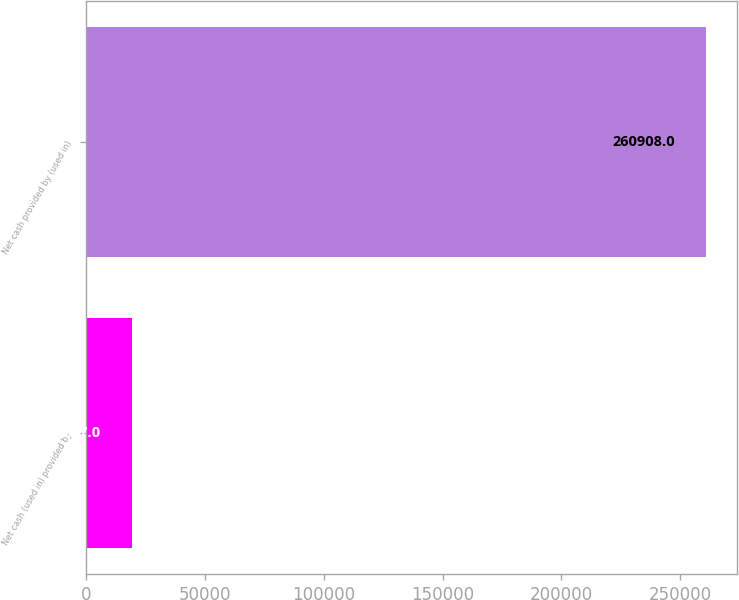Convert chart. <chart><loc_0><loc_0><loc_500><loc_500><bar_chart><fcel>Net cash (used in) provided by<fcel>Net cash provided by (used in)<nl><fcel>19217<fcel>260908<nl></chart> 